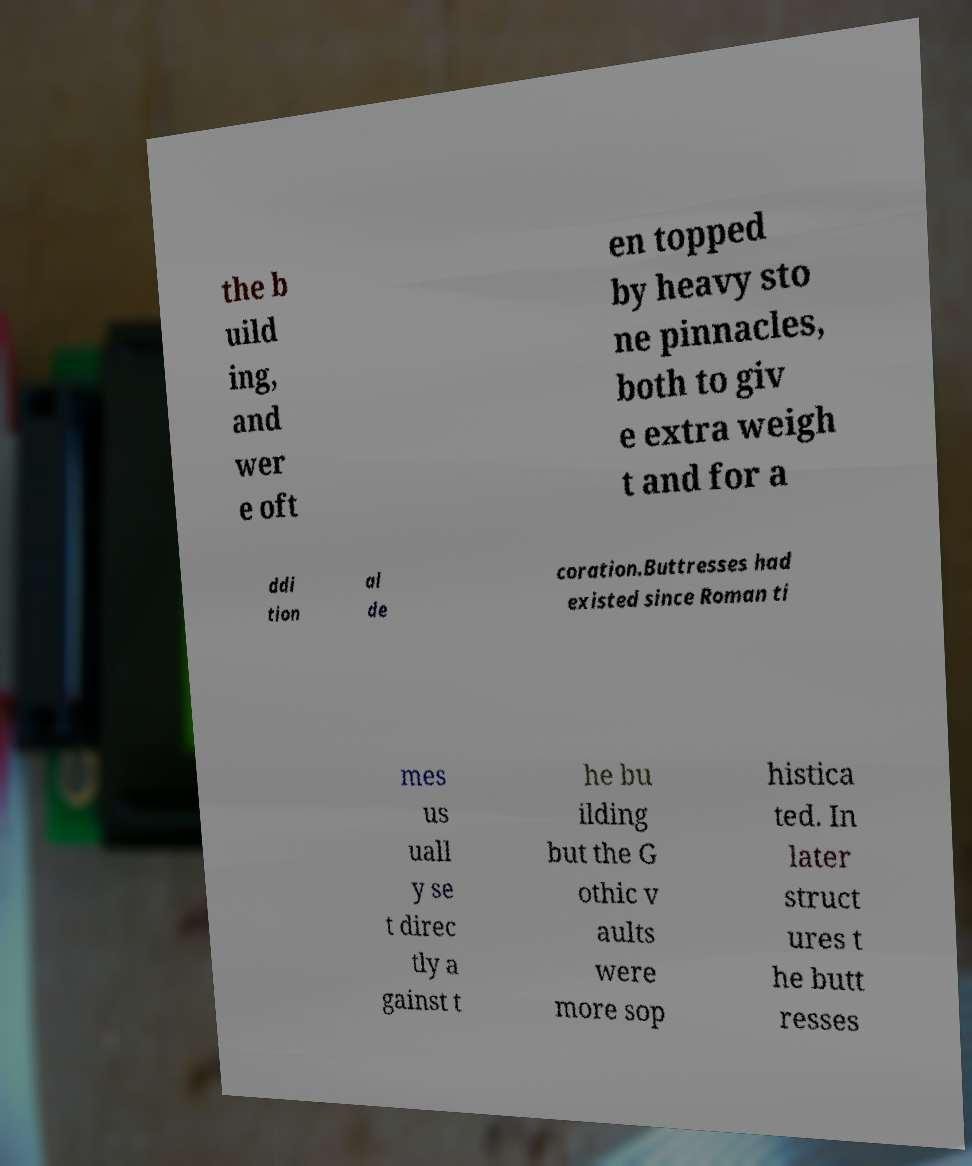Can you read and provide the text displayed in the image?This photo seems to have some interesting text. Can you extract and type it out for me? the b uild ing, and wer e oft en topped by heavy sto ne pinnacles, both to giv e extra weigh t and for a ddi tion al de coration.Buttresses had existed since Roman ti mes us uall y se t direc tly a gainst t he bu ilding but the G othic v aults were more sop histica ted. In later struct ures t he butt resses 